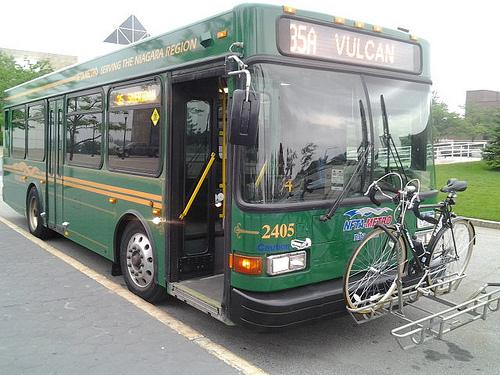List a few details about the bus in the image. The bus is green, with gold and yellow stripes, the number 2405 on the front, and an open door. What mode of transportation is present in the image and what is it carrying? The image features a bus, which is accommodating a black bicycle on a silver bike rack attached to its front. Describe the scene in the image involving a specific mode of transportation. A green bus has its doors open and is equipped with a silver bike rack, holding a black bicycle on its front. What is the most prominent color in the image and where is it visible? The most prominent color is green, visible mainly on the large bus taking up much of the image. Mention the primary focus of the image and its color. The main focus of the image is a large green bus with various details and objects surrounding it. Identify the most visually striking elements of the image and their colors. A green bus, a black bicycle on a silver rack, and a yellow number on the bus front stand out in the image. Mention the colors and types of some prominent objects in the image. The image shows a green bus, a black bicycle on a silver bike rack, a gold stripe on the side, and a yellow number on the front. Describe the interaction between the bus and another object in the image. A black bicycle is attached to the front of the green bus using a silver bike rack, showcasing its versatility. Provide a brief overview of the main elements present in the image. A large green bus with an open door, yellow number, gold stripe, bike rack with a black bicycle, and a small green tree in the background. Describe the state of the bus and the bicycle and their positions in the image. The bus doors are open, and a black bicycle is placed on the bike rack at the front of the bus. 